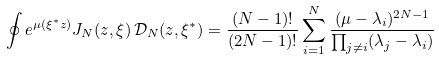Convert formula to latex. <formula><loc_0><loc_0><loc_500><loc_500>\oint e ^ { \mu ( \xi ^ { * } { z } ) } J _ { N } ( { z } , \xi ) \, \mathcal { D } _ { N } ( { z } , \xi ^ { * } ) = \frac { ( N - 1 ) ! } { ( 2 N - 1 ) ! } \sum _ { i = 1 } ^ { N } \frac { ( \mu - \lambda _ { i } ) ^ { 2 N - 1 } } { \prod _ { j \ne i } ( \lambda _ { j } - \lambda _ { i } ) }</formula> 